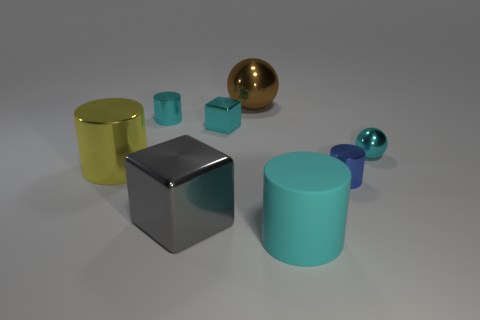Subtract all big yellow cylinders. How many cylinders are left? 3 Subtract all blue cylinders. How many cylinders are left? 3 Add 1 tiny brown cubes. How many objects exist? 9 Subtract all purple cylinders. Subtract all cyan blocks. How many cylinders are left? 4 Subtract all spheres. How many objects are left? 6 Add 7 big green cylinders. How many big green cylinders exist? 7 Subtract 1 brown spheres. How many objects are left? 7 Subtract all big cyan matte cylinders. Subtract all small shiny things. How many objects are left? 3 Add 4 tiny cyan metallic cubes. How many tiny cyan metallic cubes are left? 5 